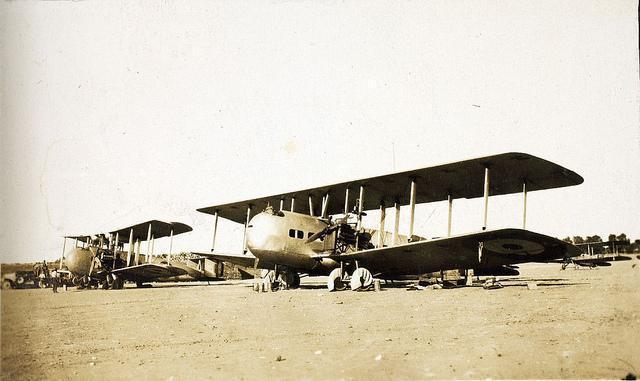How many planes are here?
Give a very brief answer. 2. How many airplanes are there?
Give a very brief answer. 2. 